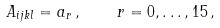Convert formula to latex. <formula><loc_0><loc_0><loc_500><loc_500>A _ { i j k l } = a _ { r } \, , \quad r = 0 , \dots , 1 5 \, ,</formula> 